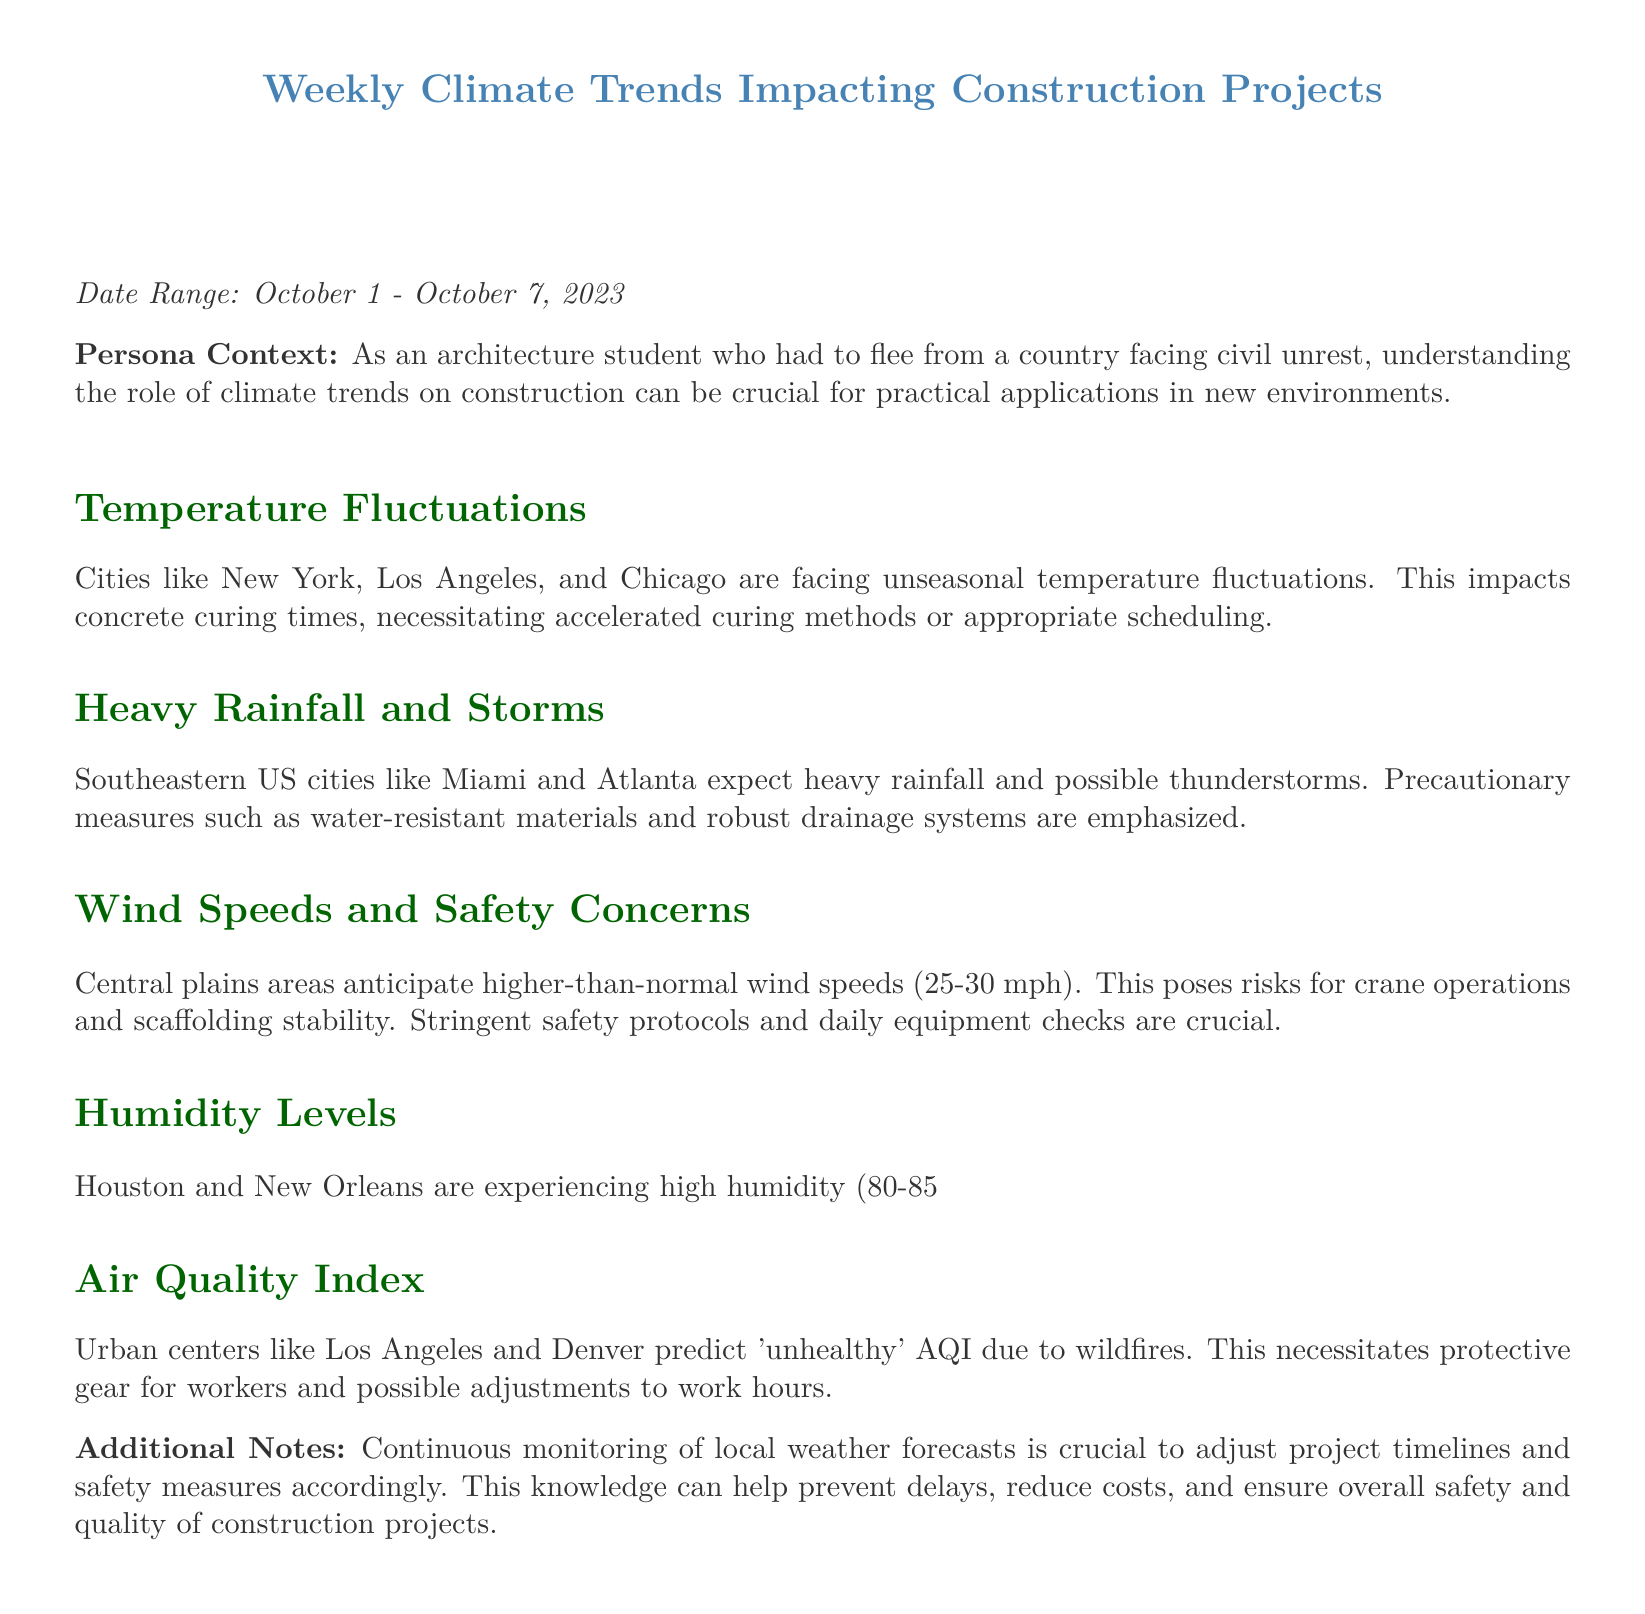What is the date range covered in the report? The date range provided in the document is specified in the introduction section.
Answer: October 1 - October 7, 2023 Which cities are mentioned as experiencing unseasonal temperature fluctuations? The document lists specific cities that are affected by temperature fluctuations in the section about temperature.
Answer: New York, Los Angeles, and Chicago What is the expected wind speed range in central plains areas? The document explicitly mentions the anticipated range of wind speeds in the related section.
Answer: 25-30 mph What humidity level is affecting Houston and New Orleans? The humidity levels for these cities are detailed in the section about humidity.
Answer: 80-85% What protective measures are suggested for urban centers with unhealthy AQI? The document describes precautions to take regarding air quality in the respective section.
Answer: Protective gear for workers Why are accelerated curing methods necessary? This requires understanding the impact of temperature fluctuations on concrete curing.
Answer: Due to unseasonal temperature fluctuations What materials are emphasized for construction in areas expecting heavy rainfall? The document points out necessary materials related to weather conditions in the heavy rainfall section.
Answer: Water-resistant materials What role does continuous monitoring of weather forecasts play? The conclusion of the document highlights the importance of monitoring weather forecasts.
Answer: Adjust project timelines and safety measures 